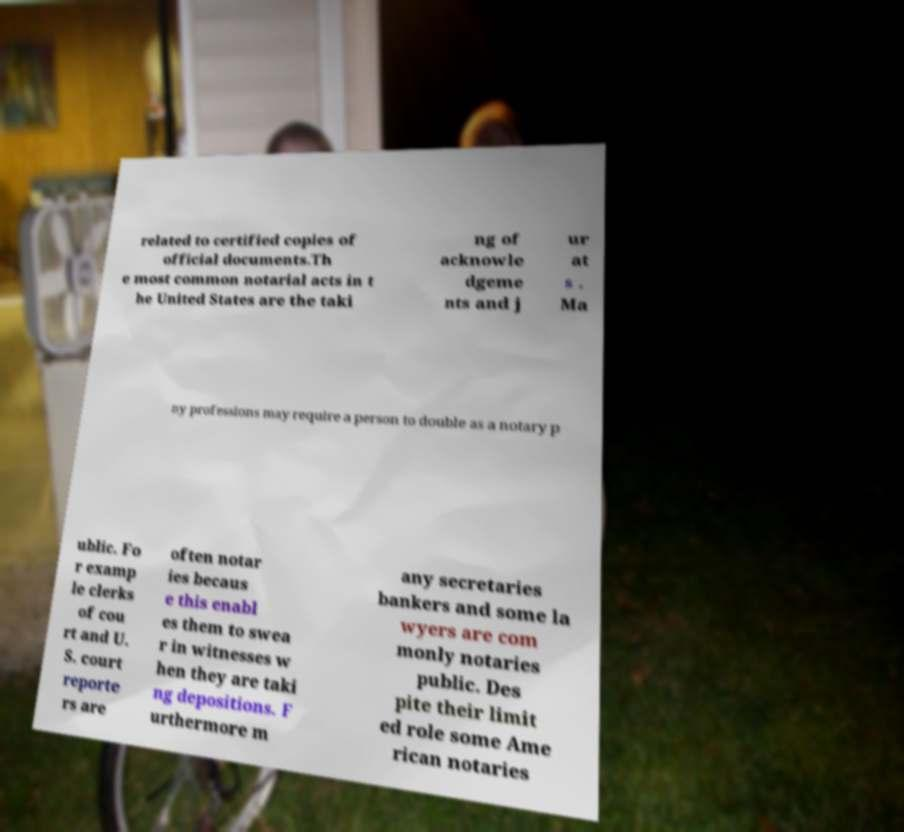Please read and relay the text visible in this image. What does it say? related to certified copies of official documents.Th e most common notarial acts in t he United States are the taki ng of acknowle dgeme nts and j ur at s . Ma ny professions may require a person to double as a notary p ublic. Fo r examp le clerks of cou rt and U. S. court reporte rs are often notar ies becaus e this enabl es them to swea r in witnesses w hen they are taki ng depositions. F urthermore m any secretaries bankers and some la wyers are com monly notaries public. Des pite their limit ed role some Ame rican notaries 